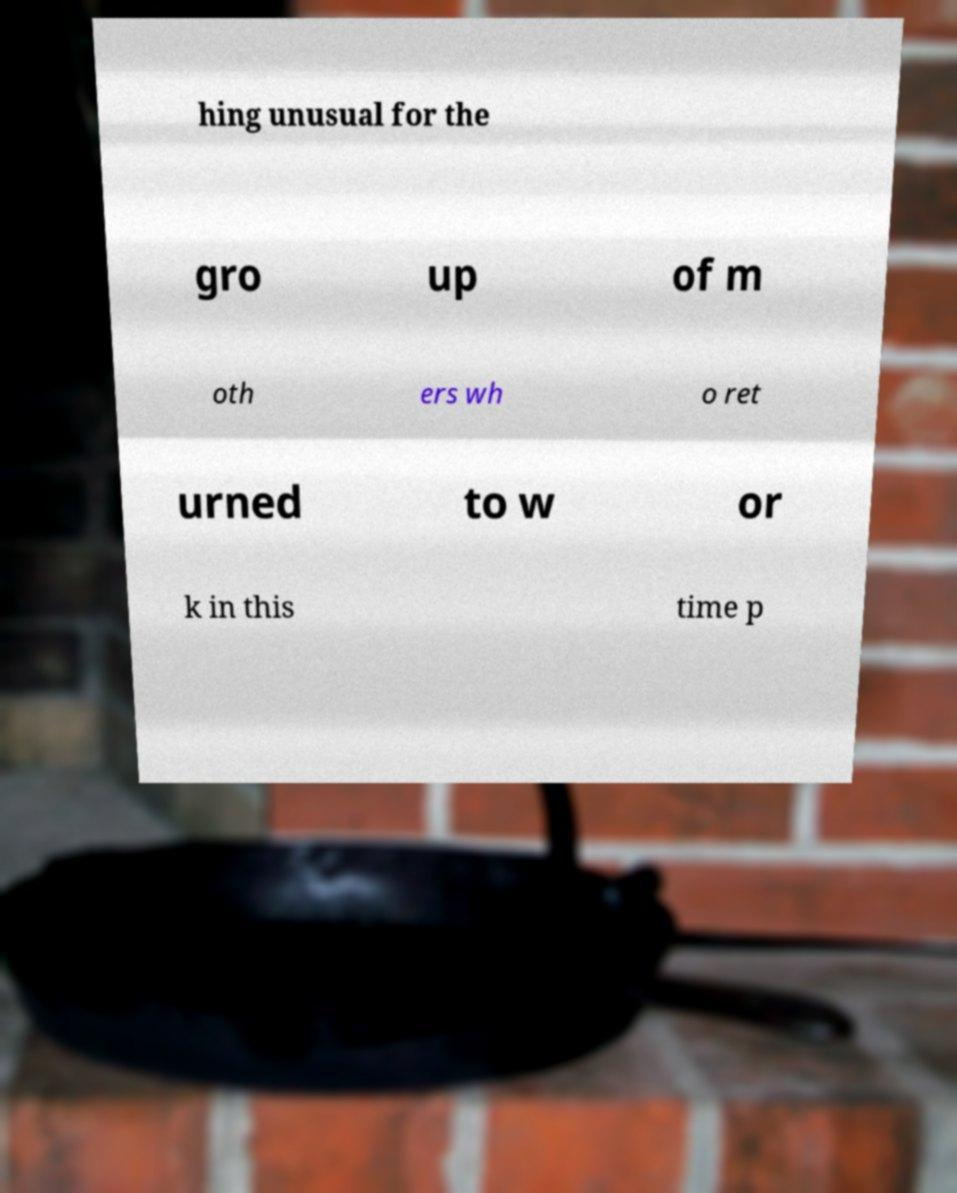Can you accurately transcribe the text from the provided image for me? hing unusual for the gro up of m oth ers wh o ret urned to w or k in this time p 